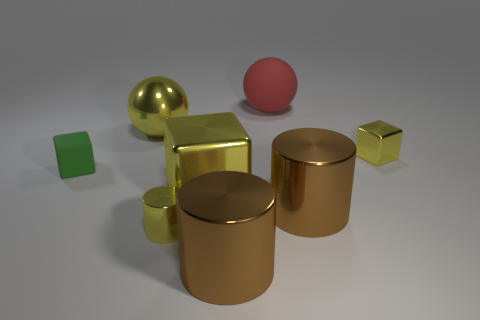Is the color of the tiny metal cube the same as the tiny shiny cylinder?
Keep it short and to the point. Yes. There is a tiny metallic object that is the same color as the small metallic block; what shape is it?
Make the answer very short. Cylinder. Do the large shiny thing that is behind the small shiny cube and the small metal object in front of the large metal block have the same color?
Give a very brief answer. Yes. Is there a small metallic thing of the same color as the metallic sphere?
Offer a terse response. Yes. Does the brown metal thing that is in front of the yellow cylinder have the same size as the tiny green rubber block?
Make the answer very short. No. Are there an equal number of yellow metal things that are in front of the rubber cube and cubes?
Offer a very short reply. No. How many objects are either big yellow metallic things in front of the green cube or tiny yellow cylinders?
Your answer should be very brief. 2. There is a tiny thing that is right of the small green rubber thing and behind the big yellow metal block; what is its shape?
Ensure brevity in your answer.  Cube. How many objects are either cubes to the right of the yellow sphere or small things that are left of the large yellow ball?
Your answer should be compact. 3. How many other things are the same size as the yellow sphere?
Ensure brevity in your answer.  4. 